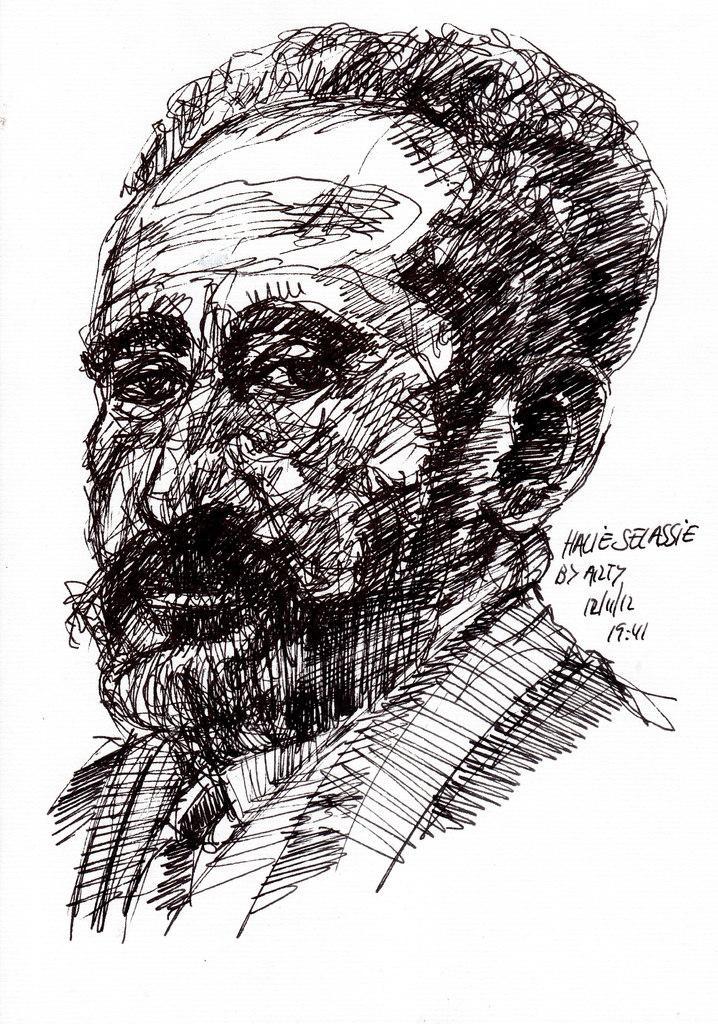Can you describe this image briefly? In the center of the image there is a drawing of a person and there is some text written. 